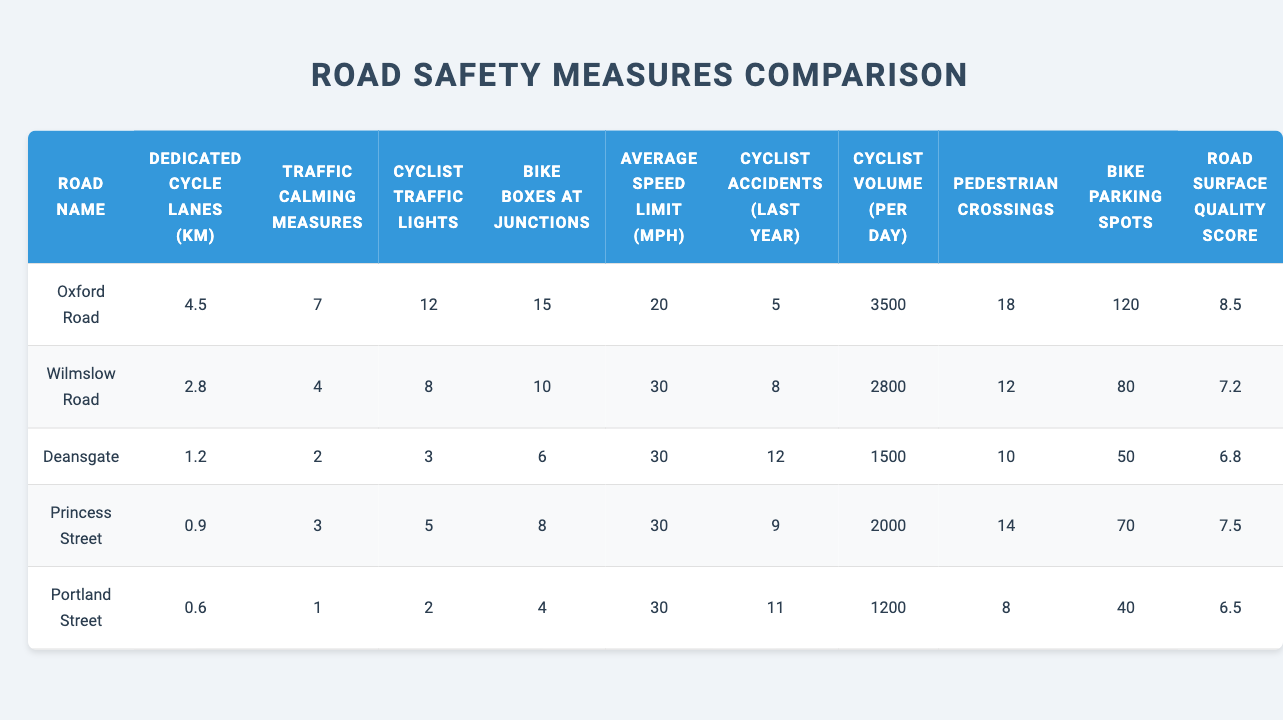What is the length of dedicated cycle lanes on Oxford Road? The table shows that the dedicated cycle lanes for Oxford Road are listed as 4.5 kilometers.
Answer: 4.5 km How many cyclist traffic lights are there on Wilmslow Road? According to the table, Wilmslow Road has 8 cyclist traffic lights.
Answer: 8 Which road has the highest average speed limit? The table states that all roads except Oxford Road have a speed limit of 30 mph. Therefore, the highest average speed limit is 30 mph.
Answer: 30 mph What is the difference in the number of pedestrian crossings between Oxford Road and Princess Street? Oxford Road has 18 pedestrian crossings, while Princess Street has 14. The difference is 18 - 14 = 4.
Answer: 4 Are there more bike boxes at junctions on Deansgate than on Portland Street? The table shows Deansgate has 6 bike boxes and Portland Street has 4. Since 6 is greater than 4, the statement is true.
Answer: Yes What is the total number of cyclist accidents reported last year across all roads? By summing the cyclist accidents for all roads: 5 (Oxford) + 8 (Wilmslow) + 12 (Deansgate) + 9 (Princess) + 11 (Portland) = 45.
Answer: 45 How many bike parking spots are available on Portland Street and Oxford Road combined? Oxford Road has 120 bike parking spots and Portland Street has 40. Adding them gives 120 + 40 = 160.
Answer: 160 Which road has the lowest road surface quality score? Referring to the table, Portland Street has the lowest road surface quality score of 6.5.
Answer: 6.5 Is the average speed limit on Oxford Road lower than on Deansgate? Oxford Road has a speed limit of 20 mph, while Deansgate has 30 mph; thus, the average speed limit on Oxford Road is lower.
Answer: Yes What is the average number of cyclist accidents for all roads except Oxford Road? The accidents for the other roads are 8, 12, 9, and 11. Summing these gives 40, and dividing by 4 roads gives an average of 40/4 = 10.
Answer: 10 